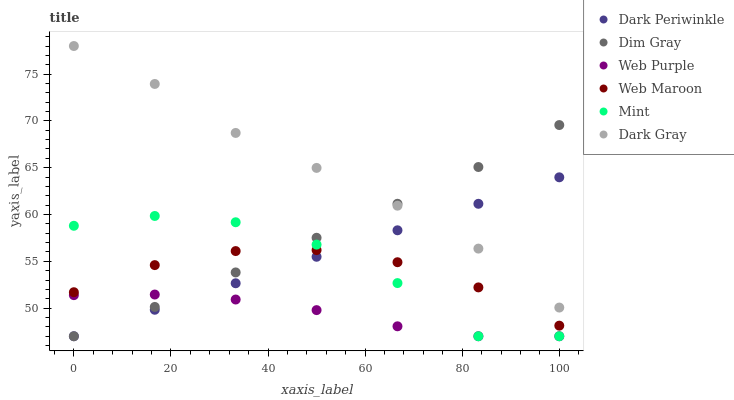Does Web Purple have the minimum area under the curve?
Answer yes or no. Yes. Does Dark Gray have the maximum area under the curve?
Answer yes or no. Yes. Does Web Maroon have the minimum area under the curve?
Answer yes or no. No. Does Web Maroon have the maximum area under the curve?
Answer yes or no. No. Is Dark Periwinkle the smoothest?
Answer yes or no. Yes. Is Mint the roughest?
Answer yes or no. Yes. Is Web Maroon the smoothest?
Answer yes or no. No. Is Web Maroon the roughest?
Answer yes or no. No. Does Dim Gray have the lowest value?
Answer yes or no. Yes. Does Web Maroon have the lowest value?
Answer yes or no. No. Does Dark Gray have the highest value?
Answer yes or no. Yes. Does Web Maroon have the highest value?
Answer yes or no. No. Is Web Purple less than Web Maroon?
Answer yes or no. Yes. Is Dark Gray greater than Web Maroon?
Answer yes or no. Yes. Does Dark Periwinkle intersect Web Purple?
Answer yes or no. Yes. Is Dark Periwinkle less than Web Purple?
Answer yes or no. No. Is Dark Periwinkle greater than Web Purple?
Answer yes or no. No. Does Web Purple intersect Web Maroon?
Answer yes or no. No. 